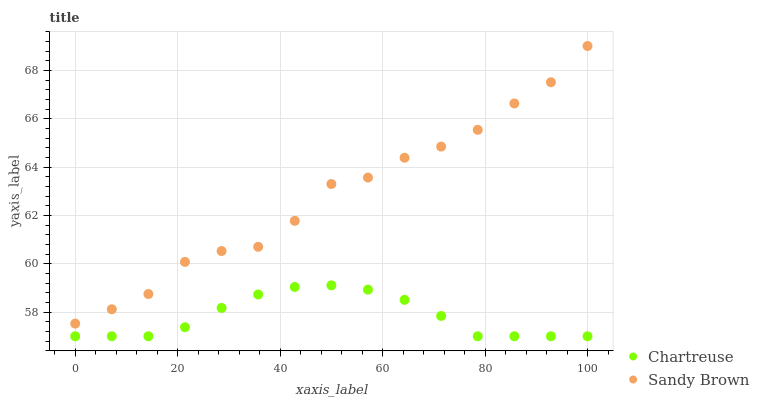Does Chartreuse have the minimum area under the curve?
Answer yes or no. Yes. Does Sandy Brown have the maximum area under the curve?
Answer yes or no. Yes. Does Sandy Brown have the minimum area under the curve?
Answer yes or no. No. Is Chartreuse the smoothest?
Answer yes or no. Yes. Is Sandy Brown the roughest?
Answer yes or no. Yes. Is Sandy Brown the smoothest?
Answer yes or no. No. Does Chartreuse have the lowest value?
Answer yes or no. Yes. Does Sandy Brown have the lowest value?
Answer yes or no. No. Does Sandy Brown have the highest value?
Answer yes or no. Yes. Is Chartreuse less than Sandy Brown?
Answer yes or no. Yes. Is Sandy Brown greater than Chartreuse?
Answer yes or no. Yes. Does Chartreuse intersect Sandy Brown?
Answer yes or no. No. 